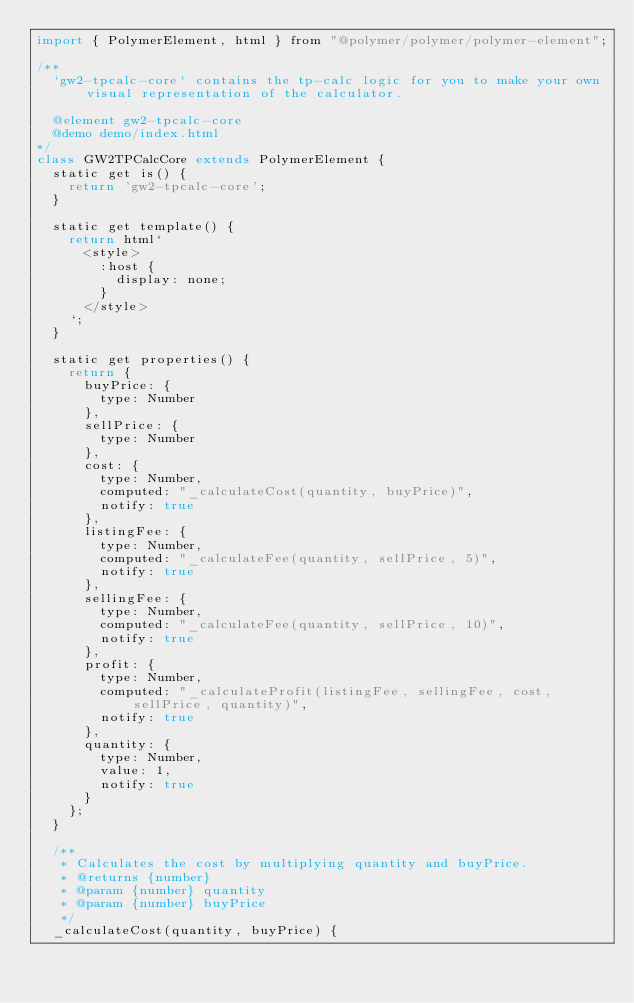<code> <loc_0><loc_0><loc_500><loc_500><_JavaScript_>import { PolymerElement, html } from "@polymer/polymer/polymer-element";

/**
  `gw2-tpcalc-core` contains the tp-calc logic for you to make your own visual representation of the calculator.

  @element gw2-tpcalc-core
  @demo demo/index.html 
*/
class GW2TPCalcCore extends PolymerElement {
  static get is() {
    return 'gw2-tpcalc-core';
  }

  static get template() {
    return html`
      <style>
        :host {
          display: none;
        }
      </style>
    `;
  }

  static get properties() {
    return {
      buyPrice: {
        type: Number
      },
      sellPrice: {
        type: Number
      },
      cost: {
        type: Number,
        computed: "_calculateCost(quantity, buyPrice)",
        notify: true
      },
      listingFee: {
        type: Number,
        computed: "_calculateFee(quantity, sellPrice, 5)",
        notify: true
      },
      sellingFee: {
        type: Number,
        computed: "_calculateFee(quantity, sellPrice, 10)",
        notify: true
      },
      profit: {
        type: Number,
        computed: "_calculateProfit(listingFee, sellingFee, cost, sellPrice, quantity)",
        notify: true
      },
      quantity: {
        type: Number,
        value: 1,
        notify: true
      }
    };
  }

  /**
   * Calculates the cost by multiplying quantity and buyPrice.
   * @returns {number}
   * @param {number} quantity
   * @param {number} buyPrice
   */
  _calculateCost(quantity, buyPrice) {</code> 